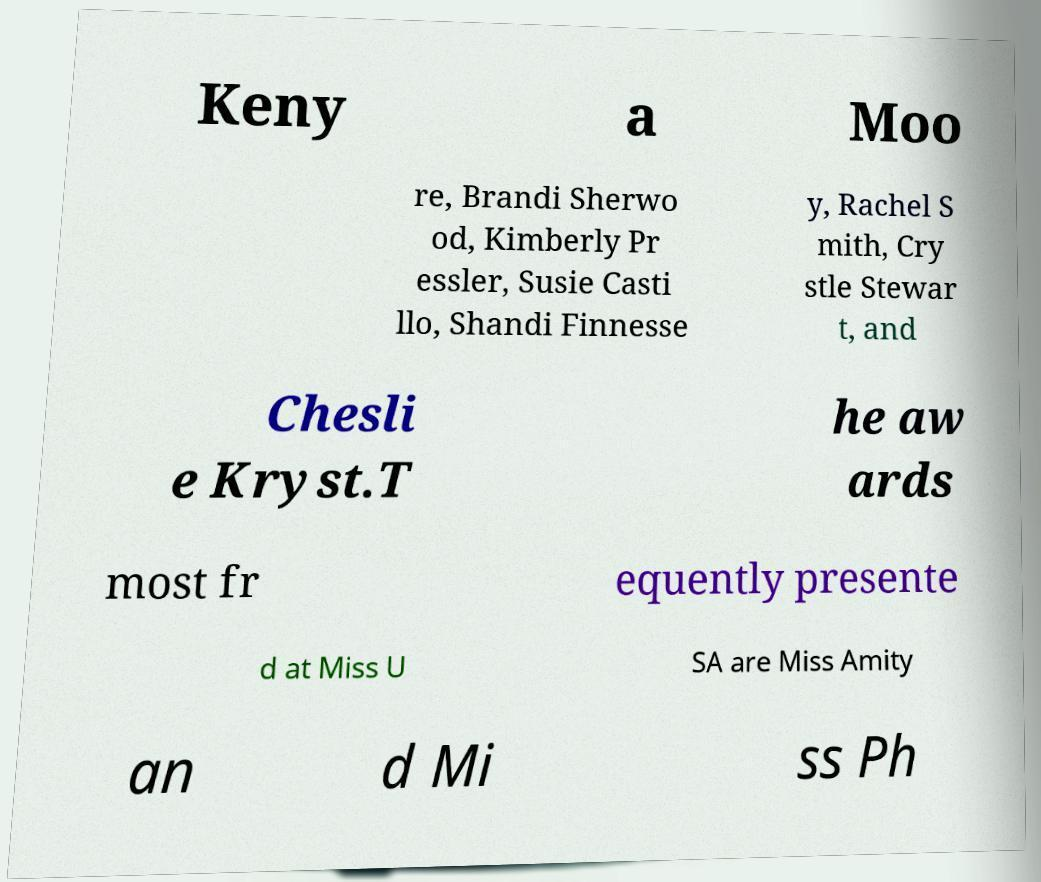Could you extract and type out the text from this image? Keny a Moo re, Brandi Sherwo od, Kimberly Pr essler, Susie Casti llo, Shandi Finnesse y, Rachel S mith, Cry stle Stewar t, and Chesli e Kryst.T he aw ards most fr equently presente d at Miss U SA are Miss Amity an d Mi ss Ph 